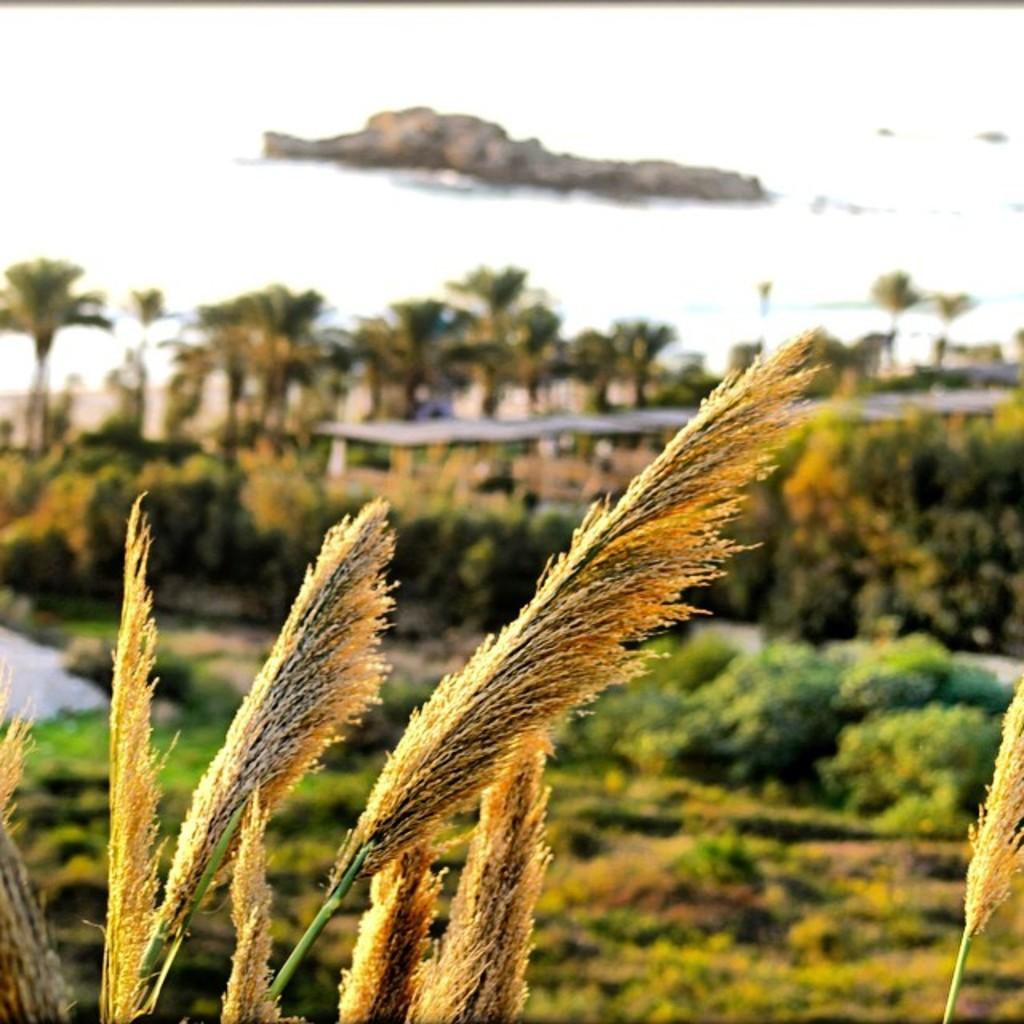What type of vegetation can be seen in the image? There are trees in the image. What natural element is also visible in the image? There is water visible in the image. What geological feature can be seen in the image? There is a rock in the image. What type of shirt is the doctor wearing in the image? There is no doctor or shirt present in the image. What is the weight of the rock in the image? The weight of the rock cannot be determined from the image alone, as it does not provide information about the rock's size or composition. 